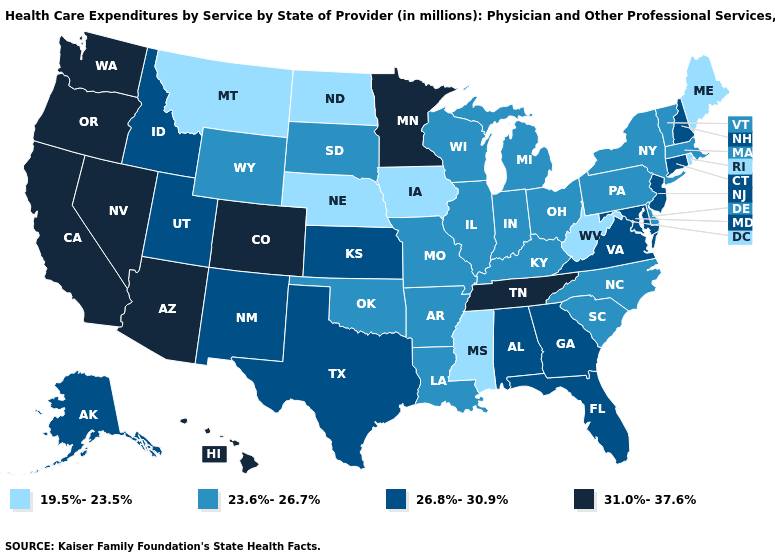What is the value of Arkansas?
Quick response, please. 23.6%-26.7%. Does the first symbol in the legend represent the smallest category?
Give a very brief answer. Yes. Name the states that have a value in the range 26.8%-30.9%?
Quick response, please. Alabama, Alaska, Connecticut, Florida, Georgia, Idaho, Kansas, Maryland, New Hampshire, New Jersey, New Mexico, Texas, Utah, Virginia. Name the states that have a value in the range 23.6%-26.7%?
Quick response, please. Arkansas, Delaware, Illinois, Indiana, Kentucky, Louisiana, Massachusetts, Michigan, Missouri, New York, North Carolina, Ohio, Oklahoma, Pennsylvania, South Carolina, South Dakota, Vermont, Wisconsin, Wyoming. Name the states that have a value in the range 19.5%-23.5%?
Keep it brief. Iowa, Maine, Mississippi, Montana, Nebraska, North Dakota, Rhode Island, West Virginia. Is the legend a continuous bar?
Quick response, please. No. Which states have the lowest value in the USA?
Concise answer only. Iowa, Maine, Mississippi, Montana, Nebraska, North Dakota, Rhode Island, West Virginia. Name the states that have a value in the range 23.6%-26.7%?
Short answer required. Arkansas, Delaware, Illinois, Indiana, Kentucky, Louisiana, Massachusetts, Michigan, Missouri, New York, North Carolina, Ohio, Oklahoma, Pennsylvania, South Carolina, South Dakota, Vermont, Wisconsin, Wyoming. What is the lowest value in the West?
Be succinct. 19.5%-23.5%. Does New Hampshire have the same value as Oklahoma?
Write a very short answer. No. Does the first symbol in the legend represent the smallest category?
Short answer required. Yes. Name the states that have a value in the range 19.5%-23.5%?
Quick response, please. Iowa, Maine, Mississippi, Montana, Nebraska, North Dakota, Rhode Island, West Virginia. Does North Carolina have the highest value in the South?
Give a very brief answer. No. Which states have the highest value in the USA?
Answer briefly. Arizona, California, Colorado, Hawaii, Minnesota, Nevada, Oregon, Tennessee, Washington. What is the value of Missouri?
Quick response, please. 23.6%-26.7%. 